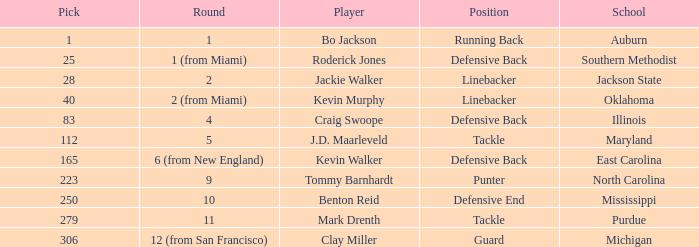What was the highest guard picked? 306.0. 